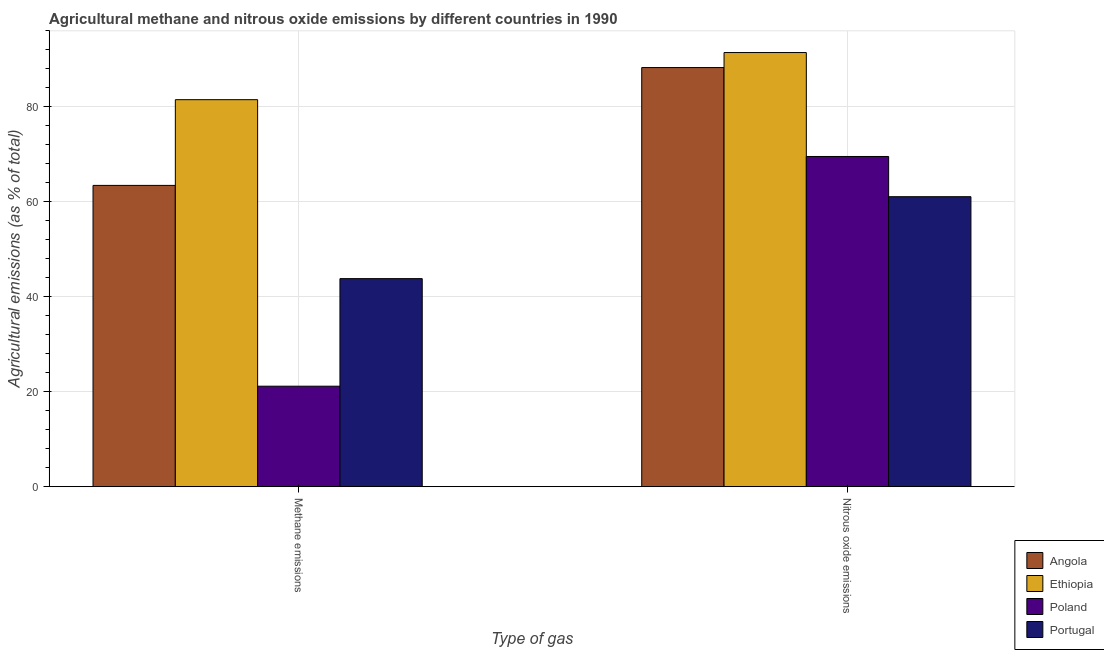How many different coloured bars are there?
Ensure brevity in your answer.  4. How many groups of bars are there?
Your answer should be compact. 2. Are the number of bars per tick equal to the number of legend labels?
Give a very brief answer. Yes. Are the number of bars on each tick of the X-axis equal?
Make the answer very short. Yes. How many bars are there on the 2nd tick from the left?
Offer a very short reply. 4. How many bars are there on the 2nd tick from the right?
Your answer should be compact. 4. What is the label of the 1st group of bars from the left?
Keep it short and to the point. Methane emissions. What is the amount of methane emissions in Angola?
Provide a succinct answer. 63.45. Across all countries, what is the maximum amount of nitrous oxide emissions?
Provide a short and direct response. 91.43. Across all countries, what is the minimum amount of methane emissions?
Your answer should be very brief. 21.16. In which country was the amount of nitrous oxide emissions maximum?
Your response must be concise. Ethiopia. What is the total amount of nitrous oxide emissions in the graph?
Give a very brief answer. 310.32. What is the difference between the amount of methane emissions in Portugal and that in Ethiopia?
Offer a terse response. -37.69. What is the difference between the amount of methane emissions in Ethiopia and the amount of nitrous oxide emissions in Poland?
Your response must be concise. 11.96. What is the average amount of methane emissions per country?
Your answer should be very brief. 52.48. What is the difference between the amount of nitrous oxide emissions and amount of methane emissions in Angola?
Provide a succinct answer. 24.82. In how many countries, is the amount of methane emissions greater than 16 %?
Ensure brevity in your answer.  4. What is the ratio of the amount of methane emissions in Ethiopia to that in Portugal?
Offer a very short reply. 1.86. Is the amount of nitrous oxide emissions in Ethiopia less than that in Angola?
Your answer should be compact. No. What does the 1st bar from the left in Methane emissions represents?
Ensure brevity in your answer.  Angola. What does the 2nd bar from the right in Methane emissions represents?
Your answer should be compact. Poland. How many bars are there?
Keep it short and to the point. 8. How many countries are there in the graph?
Make the answer very short. 4. Are the values on the major ticks of Y-axis written in scientific E-notation?
Your answer should be compact. No. Does the graph contain any zero values?
Make the answer very short. No. Where does the legend appear in the graph?
Keep it short and to the point. Bottom right. How are the legend labels stacked?
Provide a succinct answer. Vertical. What is the title of the graph?
Provide a short and direct response. Agricultural methane and nitrous oxide emissions by different countries in 1990. Does "European Union" appear as one of the legend labels in the graph?
Give a very brief answer. No. What is the label or title of the X-axis?
Give a very brief answer. Type of gas. What is the label or title of the Y-axis?
Offer a terse response. Agricultural emissions (as % of total). What is the Agricultural emissions (as % of total) of Angola in Methane emissions?
Offer a terse response. 63.45. What is the Agricultural emissions (as % of total) in Ethiopia in Methane emissions?
Provide a succinct answer. 81.5. What is the Agricultural emissions (as % of total) in Poland in Methane emissions?
Make the answer very short. 21.16. What is the Agricultural emissions (as % of total) in Portugal in Methane emissions?
Your answer should be very brief. 43.82. What is the Agricultural emissions (as % of total) of Angola in Nitrous oxide emissions?
Provide a short and direct response. 88.27. What is the Agricultural emissions (as % of total) in Ethiopia in Nitrous oxide emissions?
Ensure brevity in your answer.  91.43. What is the Agricultural emissions (as % of total) in Poland in Nitrous oxide emissions?
Make the answer very short. 69.54. What is the Agricultural emissions (as % of total) in Portugal in Nitrous oxide emissions?
Ensure brevity in your answer.  61.07. Across all Type of gas, what is the maximum Agricultural emissions (as % of total) of Angola?
Offer a terse response. 88.27. Across all Type of gas, what is the maximum Agricultural emissions (as % of total) in Ethiopia?
Offer a terse response. 91.43. Across all Type of gas, what is the maximum Agricultural emissions (as % of total) of Poland?
Provide a short and direct response. 69.54. Across all Type of gas, what is the maximum Agricultural emissions (as % of total) in Portugal?
Offer a very short reply. 61.07. Across all Type of gas, what is the minimum Agricultural emissions (as % of total) in Angola?
Provide a succinct answer. 63.45. Across all Type of gas, what is the minimum Agricultural emissions (as % of total) in Ethiopia?
Provide a short and direct response. 81.5. Across all Type of gas, what is the minimum Agricultural emissions (as % of total) in Poland?
Your response must be concise. 21.16. Across all Type of gas, what is the minimum Agricultural emissions (as % of total) in Portugal?
Offer a terse response. 43.82. What is the total Agricultural emissions (as % of total) in Angola in the graph?
Offer a terse response. 151.72. What is the total Agricultural emissions (as % of total) of Ethiopia in the graph?
Your answer should be compact. 172.94. What is the total Agricultural emissions (as % of total) of Poland in the graph?
Your answer should be compact. 90.71. What is the total Agricultural emissions (as % of total) in Portugal in the graph?
Provide a short and direct response. 104.89. What is the difference between the Agricultural emissions (as % of total) in Angola in Methane emissions and that in Nitrous oxide emissions?
Your answer should be very brief. -24.82. What is the difference between the Agricultural emissions (as % of total) in Ethiopia in Methane emissions and that in Nitrous oxide emissions?
Give a very brief answer. -9.93. What is the difference between the Agricultural emissions (as % of total) in Poland in Methane emissions and that in Nitrous oxide emissions?
Provide a short and direct response. -48.38. What is the difference between the Agricultural emissions (as % of total) in Portugal in Methane emissions and that in Nitrous oxide emissions?
Offer a terse response. -17.25. What is the difference between the Agricultural emissions (as % of total) in Angola in Methane emissions and the Agricultural emissions (as % of total) in Ethiopia in Nitrous oxide emissions?
Offer a terse response. -27.98. What is the difference between the Agricultural emissions (as % of total) of Angola in Methane emissions and the Agricultural emissions (as % of total) of Poland in Nitrous oxide emissions?
Provide a short and direct response. -6.09. What is the difference between the Agricultural emissions (as % of total) of Angola in Methane emissions and the Agricultural emissions (as % of total) of Portugal in Nitrous oxide emissions?
Offer a very short reply. 2.38. What is the difference between the Agricultural emissions (as % of total) of Ethiopia in Methane emissions and the Agricultural emissions (as % of total) of Poland in Nitrous oxide emissions?
Keep it short and to the point. 11.96. What is the difference between the Agricultural emissions (as % of total) in Ethiopia in Methane emissions and the Agricultural emissions (as % of total) in Portugal in Nitrous oxide emissions?
Offer a terse response. 20.43. What is the difference between the Agricultural emissions (as % of total) of Poland in Methane emissions and the Agricultural emissions (as % of total) of Portugal in Nitrous oxide emissions?
Your response must be concise. -39.91. What is the average Agricultural emissions (as % of total) in Angola per Type of gas?
Offer a terse response. 75.86. What is the average Agricultural emissions (as % of total) in Ethiopia per Type of gas?
Your answer should be compact. 86.47. What is the average Agricultural emissions (as % of total) in Poland per Type of gas?
Offer a very short reply. 45.35. What is the average Agricultural emissions (as % of total) in Portugal per Type of gas?
Provide a short and direct response. 52.44. What is the difference between the Agricultural emissions (as % of total) in Angola and Agricultural emissions (as % of total) in Ethiopia in Methane emissions?
Your response must be concise. -18.05. What is the difference between the Agricultural emissions (as % of total) in Angola and Agricultural emissions (as % of total) in Poland in Methane emissions?
Provide a short and direct response. 42.29. What is the difference between the Agricultural emissions (as % of total) of Angola and Agricultural emissions (as % of total) of Portugal in Methane emissions?
Provide a succinct answer. 19.63. What is the difference between the Agricultural emissions (as % of total) of Ethiopia and Agricultural emissions (as % of total) of Poland in Methane emissions?
Provide a succinct answer. 60.34. What is the difference between the Agricultural emissions (as % of total) in Ethiopia and Agricultural emissions (as % of total) in Portugal in Methane emissions?
Give a very brief answer. 37.69. What is the difference between the Agricultural emissions (as % of total) of Poland and Agricultural emissions (as % of total) of Portugal in Methane emissions?
Your answer should be compact. -22.65. What is the difference between the Agricultural emissions (as % of total) of Angola and Agricultural emissions (as % of total) of Ethiopia in Nitrous oxide emissions?
Your answer should be very brief. -3.16. What is the difference between the Agricultural emissions (as % of total) in Angola and Agricultural emissions (as % of total) in Poland in Nitrous oxide emissions?
Make the answer very short. 18.73. What is the difference between the Agricultural emissions (as % of total) of Angola and Agricultural emissions (as % of total) of Portugal in Nitrous oxide emissions?
Your answer should be very brief. 27.2. What is the difference between the Agricultural emissions (as % of total) of Ethiopia and Agricultural emissions (as % of total) of Poland in Nitrous oxide emissions?
Your answer should be compact. 21.89. What is the difference between the Agricultural emissions (as % of total) in Ethiopia and Agricultural emissions (as % of total) in Portugal in Nitrous oxide emissions?
Your response must be concise. 30.36. What is the difference between the Agricultural emissions (as % of total) in Poland and Agricultural emissions (as % of total) in Portugal in Nitrous oxide emissions?
Your answer should be very brief. 8.47. What is the ratio of the Agricultural emissions (as % of total) in Angola in Methane emissions to that in Nitrous oxide emissions?
Your response must be concise. 0.72. What is the ratio of the Agricultural emissions (as % of total) of Ethiopia in Methane emissions to that in Nitrous oxide emissions?
Give a very brief answer. 0.89. What is the ratio of the Agricultural emissions (as % of total) in Poland in Methane emissions to that in Nitrous oxide emissions?
Offer a very short reply. 0.3. What is the ratio of the Agricultural emissions (as % of total) of Portugal in Methane emissions to that in Nitrous oxide emissions?
Your answer should be compact. 0.72. What is the difference between the highest and the second highest Agricultural emissions (as % of total) in Angola?
Keep it short and to the point. 24.82. What is the difference between the highest and the second highest Agricultural emissions (as % of total) in Ethiopia?
Provide a succinct answer. 9.93. What is the difference between the highest and the second highest Agricultural emissions (as % of total) of Poland?
Ensure brevity in your answer.  48.38. What is the difference between the highest and the second highest Agricultural emissions (as % of total) in Portugal?
Ensure brevity in your answer.  17.25. What is the difference between the highest and the lowest Agricultural emissions (as % of total) in Angola?
Offer a terse response. 24.82. What is the difference between the highest and the lowest Agricultural emissions (as % of total) in Ethiopia?
Provide a succinct answer. 9.93. What is the difference between the highest and the lowest Agricultural emissions (as % of total) of Poland?
Offer a very short reply. 48.38. What is the difference between the highest and the lowest Agricultural emissions (as % of total) in Portugal?
Give a very brief answer. 17.25. 